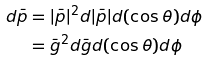<formula> <loc_0><loc_0><loc_500><loc_500>d \bar { p } & = | \bar { p } | ^ { 2 } d | \bar { p } | d ( \cos \theta ) d \phi \\ & = \bar { g } ^ { 2 } d \bar { g } d ( \cos \theta ) d \phi</formula> 